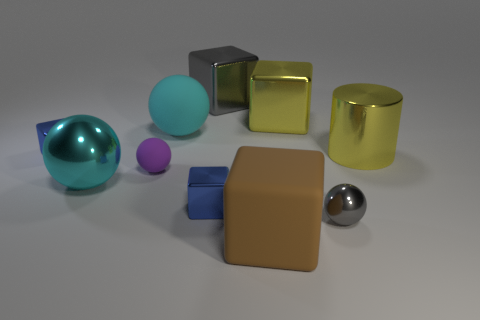What shape is the thing that is the same color as the large matte ball?
Offer a very short reply. Sphere. Does the large shiny sphere have the same color as the big rubber sphere?
Your response must be concise. Yes. Are there fewer small yellow balls than purple matte balls?
Provide a succinct answer. Yes. What number of other large metallic cylinders have the same color as the metal cylinder?
Your answer should be very brief. 0. Does the rubber ball behind the purple ball have the same color as the large shiny sphere?
Your answer should be very brief. Yes. What is the shape of the gray metallic object in front of the tiny purple sphere?
Provide a short and direct response. Sphere. Are there any yellow cylinders in front of the big yellow metallic object that is right of the tiny gray metal sphere?
Provide a succinct answer. No. How many tiny cubes have the same material as the small purple object?
Offer a very short reply. 0. What size is the blue metal object left of the big cyan ball that is behind the small blue block left of the cyan metallic thing?
Provide a succinct answer. Small. What number of metal objects are left of the large gray metallic block?
Make the answer very short. 3. 